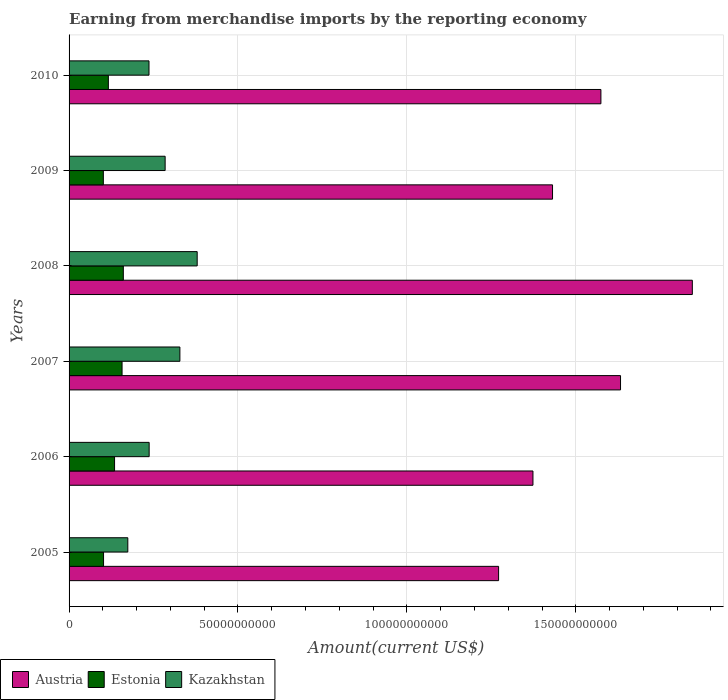Are the number of bars per tick equal to the number of legend labels?
Your answer should be very brief. Yes. What is the label of the 1st group of bars from the top?
Provide a short and direct response. 2010. What is the amount earned from merchandise imports in Kazakhstan in 2008?
Your response must be concise. 3.79e+1. Across all years, what is the maximum amount earned from merchandise imports in Kazakhstan?
Offer a terse response. 3.79e+1. Across all years, what is the minimum amount earned from merchandise imports in Austria?
Make the answer very short. 1.27e+11. In which year was the amount earned from merchandise imports in Austria minimum?
Give a very brief answer. 2005. What is the total amount earned from merchandise imports in Austria in the graph?
Give a very brief answer. 9.13e+11. What is the difference between the amount earned from merchandise imports in Estonia in 2007 and that in 2009?
Ensure brevity in your answer.  5.54e+09. What is the difference between the amount earned from merchandise imports in Kazakhstan in 2006 and the amount earned from merchandise imports in Austria in 2009?
Offer a terse response. -1.19e+11. What is the average amount earned from merchandise imports in Estonia per year?
Keep it short and to the point. 1.29e+1. In the year 2009, what is the difference between the amount earned from merchandise imports in Estonia and amount earned from merchandise imports in Kazakhstan?
Your response must be concise. -1.83e+1. What is the ratio of the amount earned from merchandise imports in Estonia in 2006 to that in 2009?
Your answer should be compact. 1.33. Is the amount earned from merchandise imports in Kazakhstan in 2008 less than that in 2010?
Provide a succinct answer. No. What is the difference between the highest and the second highest amount earned from merchandise imports in Estonia?
Ensure brevity in your answer.  3.73e+08. What is the difference between the highest and the lowest amount earned from merchandise imports in Estonia?
Make the answer very short. 5.91e+09. What does the 3rd bar from the top in 2008 represents?
Make the answer very short. Austria. What does the 3rd bar from the bottom in 2007 represents?
Keep it short and to the point. Kazakhstan. Is it the case that in every year, the sum of the amount earned from merchandise imports in Austria and amount earned from merchandise imports in Estonia is greater than the amount earned from merchandise imports in Kazakhstan?
Offer a very short reply. Yes. Are all the bars in the graph horizontal?
Offer a terse response. Yes. What is the difference between two consecutive major ticks on the X-axis?
Provide a short and direct response. 5.00e+1. Does the graph contain any zero values?
Keep it short and to the point. No. Where does the legend appear in the graph?
Offer a terse response. Bottom left. What is the title of the graph?
Offer a very short reply. Earning from merchandise imports by the reporting economy. What is the label or title of the X-axis?
Keep it short and to the point. Amount(current US$). What is the label or title of the Y-axis?
Offer a terse response. Years. What is the Amount(current US$) of Austria in 2005?
Give a very brief answer. 1.27e+11. What is the Amount(current US$) in Estonia in 2005?
Provide a short and direct response. 1.02e+1. What is the Amount(current US$) in Kazakhstan in 2005?
Offer a very short reply. 1.74e+1. What is the Amount(current US$) of Austria in 2006?
Your answer should be very brief. 1.37e+11. What is the Amount(current US$) of Estonia in 2006?
Your response must be concise. 1.35e+1. What is the Amount(current US$) of Kazakhstan in 2006?
Offer a very short reply. 2.37e+1. What is the Amount(current US$) of Austria in 2007?
Your answer should be very brief. 1.63e+11. What is the Amount(current US$) of Estonia in 2007?
Keep it short and to the point. 1.57e+1. What is the Amount(current US$) of Kazakhstan in 2007?
Provide a succinct answer. 3.28e+1. What is the Amount(current US$) in Austria in 2008?
Your response must be concise. 1.85e+11. What is the Amount(current US$) in Estonia in 2008?
Offer a very short reply. 1.61e+1. What is the Amount(current US$) of Kazakhstan in 2008?
Make the answer very short. 3.79e+1. What is the Amount(current US$) in Austria in 2009?
Provide a short and direct response. 1.43e+11. What is the Amount(current US$) of Estonia in 2009?
Your answer should be very brief. 1.01e+1. What is the Amount(current US$) of Kazakhstan in 2009?
Make the answer very short. 2.84e+1. What is the Amount(current US$) in Austria in 2010?
Offer a very short reply. 1.57e+11. What is the Amount(current US$) in Estonia in 2010?
Your response must be concise. 1.16e+1. What is the Amount(current US$) in Kazakhstan in 2010?
Provide a succinct answer. 2.37e+1. Across all years, what is the maximum Amount(current US$) of Austria?
Ensure brevity in your answer.  1.85e+11. Across all years, what is the maximum Amount(current US$) in Estonia?
Provide a short and direct response. 1.61e+1. Across all years, what is the maximum Amount(current US$) in Kazakhstan?
Ensure brevity in your answer.  3.79e+1. Across all years, what is the minimum Amount(current US$) in Austria?
Give a very brief answer. 1.27e+11. Across all years, what is the minimum Amount(current US$) of Estonia?
Provide a short and direct response. 1.01e+1. Across all years, what is the minimum Amount(current US$) in Kazakhstan?
Your response must be concise. 1.74e+1. What is the total Amount(current US$) of Austria in the graph?
Your response must be concise. 9.13e+11. What is the total Amount(current US$) of Estonia in the graph?
Your response must be concise. 7.72e+1. What is the total Amount(current US$) in Kazakhstan in the graph?
Give a very brief answer. 1.64e+11. What is the difference between the Amount(current US$) in Austria in 2005 and that in 2006?
Offer a very short reply. -1.02e+1. What is the difference between the Amount(current US$) in Estonia in 2005 and that in 2006?
Provide a succinct answer. -3.26e+09. What is the difference between the Amount(current US$) in Kazakhstan in 2005 and that in 2006?
Offer a terse response. -6.32e+09. What is the difference between the Amount(current US$) of Austria in 2005 and that in 2007?
Keep it short and to the point. -3.61e+1. What is the difference between the Amount(current US$) of Estonia in 2005 and that in 2007?
Your answer should be compact. -5.48e+09. What is the difference between the Amount(current US$) of Kazakhstan in 2005 and that in 2007?
Offer a terse response. -1.54e+1. What is the difference between the Amount(current US$) of Austria in 2005 and that in 2008?
Your response must be concise. -5.74e+1. What is the difference between the Amount(current US$) in Estonia in 2005 and that in 2008?
Provide a succinct answer. -5.85e+09. What is the difference between the Amount(current US$) of Kazakhstan in 2005 and that in 2008?
Offer a very short reply. -2.05e+1. What is the difference between the Amount(current US$) in Austria in 2005 and that in 2009?
Your answer should be very brief. -1.60e+1. What is the difference between the Amount(current US$) of Estonia in 2005 and that in 2009?
Provide a short and direct response. 6.10e+07. What is the difference between the Amount(current US$) in Kazakhstan in 2005 and that in 2009?
Provide a short and direct response. -1.11e+1. What is the difference between the Amount(current US$) in Austria in 2005 and that in 2010?
Offer a very short reply. -3.03e+1. What is the difference between the Amount(current US$) in Estonia in 2005 and that in 2010?
Give a very brief answer. -1.42e+09. What is the difference between the Amount(current US$) of Kazakhstan in 2005 and that in 2010?
Keep it short and to the point. -6.27e+09. What is the difference between the Amount(current US$) of Austria in 2006 and that in 2007?
Keep it short and to the point. -2.59e+1. What is the difference between the Amount(current US$) in Estonia in 2006 and that in 2007?
Your answer should be very brief. -2.22e+09. What is the difference between the Amount(current US$) in Kazakhstan in 2006 and that in 2007?
Your answer should be compact. -9.10e+09. What is the difference between the Amount(current US$) in Austria in 2006 and that in 2008?
Keep it short and to the point. -4.72e+1. What is the difference between the Amount(current US$) of Estonia in 2006 and that in 2008?
Offer a very short reply. -2.60e+09. What is the difference between the Amount(current US$) in Kazakhstan in 2006 and that in 2008?
Your response must be concise. -1.42e+1. What is the difference between the Amount(current US$) in Austria in 2006 and that in 2009?
Your answer should be compact. -5.80e+09. What is the difference between the Amount(current US$) in Estonia in 2006 and that in 2009?
Ensure brevity in your answer.  3.32e+09. What is the difference between the Amount(current US$) in Kazakhstan in 2006 and that in 2009?
Keep it short and to the point. -4.73e+09. What is the difference between the Amount(current US$) of Austria in 2006 and that in 2010?
Your answer should be very brief. -2.01e+1. What is the difference between the Amount(current US$) of Estonia in 2006 and that in 2010?
Your answer should be very brief. 1.84e+09. What is the difference between the Amount(current US$) in Kazakhstan in 2006 and that in 2010?
Keep it short and to the point. 4.84e+07. What is the difference between the Amount(current US$) in Austria in 2007 and that in 2008?
Provide a short and direct response. -2.13e+1. What is the difference between the Amount(current US$) in Estonia in 2007 and that in 2008?
Your answer should be very brief. -3.73e+08. What is the difference between the Amount(current US$) of Kazakhstan in 2007 and that in 2008?
Offer a terse response. -5.12e+09. What is the difference between the Amount(current US$) of Austria in 2007 and that in 2009?
Make the answer very short. 2.01e+1. What is the difference between the Amount(current US$) in Estonia in 2007 and that in 2009?
Keep it short and to the point. 5.54e+09. What is the difference between the Amount(current US$) of Kazakhstan in 2007 and that in 2009?
Provide a short and direct response. 4.37e+09. What is the difference between the Amount(current US$) of Austria in 2007 and that in 2010?
Provide a short and direct response. 5.81e+09. What is the difference between the Amount(current US$) of Estonia in 2007 and that in 2010?
Give a very brief answer. 4.06e+09. What is the difference between the Amount(current US$) of Kazakhstan in 2007 and that in 2010?
Give a very brief answer. 9.14e+09. What is the difference between the Amount(current US$) of Austria in 2008 and that in 2009?
Ensure brevity in your answer.  4.14e+1. What is the difference between the Amount(current US$) of Estonia in 2008 and that in 2009?
Provide a succinct answer. 5.91e+09. What is the difference between the Amount(current US$) of Kazakhstan in 2008 and that in 2009?
Offer a very short reply. 9.49e+09. What is the difference between the Amount(current US$) of Austria in 2008 and that in 2010?
Your response must be concise. 2.71e+1. What is the difference between the Amount(current US$) in Estonia in 2008 and that in 2010?
Ensure brevity in your answer.  4.43e+09. What is the difference between the Amount(current US$) of Kazakhstan in 2008 and that in 2010?
Your answer should be very brief. 1.43e+1. What is the difference between the Amount(current US$) in Austria in 2009 and that in 2010?
Give a very brief answer. -1.43e+1. What is the difference between the Amount(current US$) of Estonia in 2009 and that in 2010?
Offer a terse response. -1.48e+09. What is the difference between the Amount(current US$) in Kazakhstan in 2009 and that in 2010?
Your response must be concise. 4.78e+09. What is the difference between the Amount(current US$) in Austria in 2005 and the Amount(current US$) in Estonia in 2006?
Your answer should be very brief. 1.14e+11. What is the difference between the Amount(current US$) in Austria in 2005 and the Amount(current US$) in Kazakhstan in 2006?
Your answer should be very brief. 1.03e+11. What is the difference between the Amount(current US$) of Estonia in 2005 and the Amount(current US$) of Kazakhstan in 2006?
Make the answer very short. -1.35e+1. What is the difference between the Amount(current US$) in Austria in 2005 and the Amount(current US$) in Estonia in 2007?
Offer a very short reply. 1.11e+11. What is the difference between the Amount(current US$) in Austria in 2005 and the Amount(current US$) in Kazakhstan in 2007?
Offer a very short reply. 9.43e+1. What is the difference between the Amount(current US$) of Estonia in 2005 and the Amount(current US$) of Kazakhstan in 2007?
Your response must be concise. -2.26e+1. What is the difference between the Amount(current US$) of Austria in 2005 and the Amount(current US$) of Estonia in 2008?
Ensure brevity in your answer.  1.11e+11. What is the difference between the Amount(current US$) in Austria in 2005 and the Amount(current US$) in Kazakhstan in 2008?
Offer a terse response. 8.92e+1. What is the difference between the Amount(current US$) in Estonia in 2005 and the Amount(current US$) in Kazakhstan in 2008?
Your answer should be compact. -2.77e+1. What is the difference between the Amount(current US$) of Austria in 2005 and the Amount(current US$) of Estonia in 2009?
Provide a succinct answer. 1.17e+11. What is the difference between the Amount(current US$) in Austria in 2005 and the Amount(current US$) in Kazakhstan in 2009?
Provide a short and direct response. 9.87e+1. What is the difference between the Amount(current US$) in Estonia in 2005 and the Amount(current US$) in Kazakhstan in 2009?
Keep it short and to the point. -1.82e+1. What is the difference between the Amount(current US$) in Austria in 2005 and the Amount(current US$) in Estonia in 2010?
Provide a succinct answer. 1.16e+11. What is the difference between the Amount(current US$) of Austria in 2005 and the Amount(current US$) of Kazakhstan in 2010?
Ensure brevity in your answer.  1.03e+11. What is the difference between the Amount(current US$) in Estonia in 2005 and the Amount(current US$) in Kazakhstan in 2010?
Keep it short and to the point. -1.35e+1. What is the difference between the Amount(current US$) in Austria in 2006 and the Amount(current US$) in Estonia in 2007?
Provide a short and direct response. 1.22e+11. What is the difference between the Amount(current US$) in Austria in 2006 and the Amount(current US$) in Kazakhstan in 2007?
Your answer should be very brief. 1.05e+11. What is the difference between the Amount(current US$) of Estonia in 2006 and the Amount(current US$) of Kazakhstan in 2007?
Provide a short and direct response. -1.93e+1. What is the difference between the Amount(current US$) in Austria in 2006 and the Amount(current US$) in Estonia in 2008?
Offer a very short reply. 1.21e+11. What is the difference between the Amount(current US$) of Austria in 2006 and the Amount(current US$) of Kazakhstan in 2008?
Your answer should be compact. 9.94e+1. What is the difference between the Amount(current US$) in Estonia in 2006 and the Amount(current US$) in Kazakhstan in 2008?
Ensure brevity in your answer.  -2.45e+1. What is the difference between the Amount(current US$) of Austria in 2006 and the Amount(current US$) of Estonia in 2009?
Provide a succinct answer. 1.27e+11. What is the difference between the Amount(current US$) of Austria in 2006 and the Amount(current US$) of Kazakhstan in 2009?
Offer a terse response. 1.09e+11. What is the difference between the Amount(current US$) of Estonia in 2006 and the Amount(current US$) of Kazakhstan in 2009?
Make the answer very short. -1.50e+1. What is the difference between the Amount(current US$) in Austria in 2006 and the Amount(current US$) in Estonia in 2010?
Give a very brief answer. 1.26e+11. What is the difference between the Amount(current US$) in Austria in 2006 and the Amount(current US$) in Kazakhstan in 2010?
Your response must be concise. 1.14e+11. What is the difference between the Amount(current US$) of Estonia in 2006 and the Amount(current US$) of Kazakhstan in 2010?
Offer a terse response. -1.02e+1. What is the difference between the Amount(current US$) of Austria in 2007 and the Amount(current US$) of Estonia in 2008?
Your response must be concise. 1.47e+11. What is the difference between the Amount(current US$) in Austria in 2007 and the Amount(current US$) in Kazakhstan in 2008?
Offer a very short reply. 1.25e+11. What is the difference between the Amount(current US$) in Estonia in 2007 and the Amount(current US$) in Kazakhstan in 2008?
Give a very brief answer. -2.22e+1. What is the difference between the Amount(current US$) of Austria in 2007 and the Amount(current US$) of Estonia in 2009?
Keep it short and to the point. 1.53e+11. What is the difference between the Amount(current US$) of Austria in 2007 and the Amount(current US$) of Kazakhstan in 2009?
Provide a short and direct response. 1.35e+11. What is the difference between the Amount(current US$) of Estonia in 2007 and the Amount(current US$) of Kazakhstan in 2009?
Your response must be concise. -1.27e+1. What is the difference between the Amount(current US$) in Austria in 2007 and the Amount(current US$) in Estonia in 2010?
Offer a terse response. 1.52e+11. What is the difference between the Amount(current US$) in Austria in 2007 and the Amount(current US$) in Kazakhstan in 2010?
Offer a terse response. 1.40e+11. What is the difference between the Amount(current US$) in Estonia in 2007 and the Amount(current US$) in Kazakhstan in 2010?
Your answer should be compact. -7.97e+09. What is the difference between the Amount(current US$) of Austria in 2008 and the Amount(current US$) of Estonia in 2009?
Provide a short and direct response. 1.74e+11. What is the difference between the Amount(current US$) of Austria in 2008 and the Amount(current US$) of Kazakhstan in 2009?
Your response must be concise. 1.56e+11. What is the difference between the Amount(current US$) in Estonia in 2008 and the Amount(current US$) in Kazakhstan in 2009?
Make the answer very short. -1.24e+1. What is the difference between the Amount(current US$) of Austria in 2008 and the Amount(current US$) of Estonia in 2010?
Provide a short and direct response. 1.73e+11. What is the difference between the Amount(current US$) of Austria in 2008 and the Amount(current US$) of Kazakhstan in 2010?
Offer a very short reply. 1.61e+11. What is the difference between the Amount(current US$) in Estonia in 2008 and the Amount(current US$) in Kazakhstan in 2010?
Offer a terse response. -7.60e+09. What is the difference between the Amount(current US$) in Austria in 2009 and the Amount(current US$) in Estonia in 2010?
Offer a very short reply. 1.31e+11. What is the difference between the Amount(current US$) of Austria in 2009 and the Amount(current US$) of Kazakhstan in 2010?
Provide a succinct answer. 1.19e+11. What is the difference between the Amount(current US$) of Estonia in 2009 and the Amount(current US$) of Kazakhstan in 2010?
Give a very brief answer. -1.35e+1. What is the average Amount(current US$) of Austria per year?
Keep it short and to the point. 1.52e+11. What is the average Amount(current US$) of Estonia per year?
Your answer should be compact. 1.29e+1. What is the average Amount(current US$) of Kazakhstan per year?
Your answer should be compact. 2.73e+1. In the year 2005, what is the difference between the Amount(current US$) of Austria and Amount(current US$) of Estonia?
Ensure brevity in your answer.  1.17e+11. In the year 2005, what is the difference between the Amount(current US$) of Austria and Amount(current US$) of Kazakhstan?
Make the answer very short. 1.10e+11. In the year 2005, what is the difference between the Amount(current US$) in Estonia and Amount(current US$) in Kazakhstan?
Provide a succinct answer. -7.18e+09. In the year 2006, what is the difference between the Amount(current US$) of Austria and Amount(current US$) of Estonia?
Offer a terse response. 1.24e+11. In the year 2006, what is the difference between the Amount(current US$) of Austria and Amount(current US$) of Kazakhstan?
Ensure brevity in your answer.  1.14e+11. In the year 2006, what is the difference between the Amount(current US$) in Estonia and Amount(current US$) in Kazakhstan?
Keep it short and to the point. -1.02e+1. In the year 2007, what is the difference between the Amount(current US$) of Austria and Amount(current US$) of Estonia?
Your answer should be very brief. 1.48e+11. In the year 2007, what is the difference between the Amount(current US$) of Austria and Amount(current US$) of Kazakhstan?
Give a very brief answer. 1.30e+11. In the year 2007, what is the difference between the Amount(current US$) in Estonia and Amount(current US$) in Kazakhstan?
Ensure brevity in your answer.  -1.71e+1. In the year 2008, what is the difference between the Amount(current US$) of Austria and Amount(current US$) of Estonia?
Your response must be concise. 1.68e+11. In the year 2008, what is the difference between the Amount(current US$) in Austria and Amount(current US$) in Kazakhstan?
Make the answer very short. 1.47e+11. In the year 2008, what is the difference between the Amount(current US$) of Estonia and Amount(current US$) of Kazakhstan?
Your answer should be very brief. -2.19e+1. In the year 2009, what is the difference between the Amount(current US$) of Austria and Amount(current US$) of Estonia?
Offer a terse response. 1.33e+11. In the year 2009, what is the difference between the Amount(current US$) in Austria and Amount(current US$) in Kazakhstan?
Give a very brief answer. 1.15e+11. In the year 2009, what is the difference between the Amount(current US$) of Estonia and Amount(current US$) of Kazakhstan?
Your response must be concise. -1.83e+1. In the year 2010, what is the difference between the Amount(current US$) in Austria and Amount(current US$) in Estonia?
Provide a succinct answer. 1.46e+11. In the year 2010, what is the difference between the Amount(current US$) of Austria and Amount(current US$) of Kazakhstan?
Provide a short and direct response. 1.34e+11. In the year 2010, what is the difference between the Amount(current US$) in Estonia and Amount(current US$) in Kazakhstan?
Make the answer very short. -1.20e+1. What is the ratio of the Amount(current US$) of Austria in 2005 to that in 2006?
Offer a very short reply. 0.93. What is the ratio of the Amount(current US$) of Estonia in 2005 to that in 2006?
Make the answer very short. 0.76. What is the ratio of the Amount(current US$) in Kazakhstan in 2005 to that in 2006?
Provide a short and direct response. 0.73. What is the ratio of the Amount(current US$) of Austria in 2005 to that in 2007?
Make the answer very short. 0.78. What is the ratio of the Amount(current US$) of Estonia in 2005 to that in 2007?
Keep it short and to the point. 0.65. What is the ratio of the Amount(current US$) of Kazakhstan in 2005 to that in 2007?
Your response must be concise. 0.53. What is the ratio of the Amount(current US$) in Austria in 2005 to that in 2008?
Keep it short and to the point. 0.69. What is the ratio of the Amount(current US$) of Estonia in 2005 to that in 2008?
Your answer should be very brief. 0.64. What is the ratio of the Amount(current US$) in Kazakhstan in 2005 to that in 2008?
Provide a short and direct response. 0.46. What is the ratio of the Amount(current US$) in Austria in 2005 to that in 2009?
Provide a short and direct response. 0.89. What is the ratio of the Amount(current US$) in Estonia in 2005 to that in 2009?
Provide a succinct answer. 1.01. What is the ratio of the Amount(current US$) in Kazakhstan in 2005 to that in 2009?
Make the answer very short. 0.61. What is the ratio of the Amount(current US$) of Austria in 2005 to that in 2010?
Your response must be concise. 0.81. What is the ratio of the Amount(current US$) in Estonia in 2005 to that in 2010?
Keep it short and to the point. 0.88. What is the ratio of the Amount(current US$) in Kazakhstan in 2005 to that in 2010?
Provide a short and direct response. 0.73. What is the ratio of the Amount(current US$) in Austria in 2006 to that in 2007?
Keep it short and to the point. 0.84. What is the ratio of the Amount(current US$) of Estonia in 2006 to that in 2007?
Provide a short and direct response. 0.86. What is the ratio of the Amount(current US$) in Kazakhstan in 2006 to that in 2007?
Your answer should be very brief. 0.72. What is the ratio of the Amount(current US$) of Austria in 2006 to that in 2008?
Offer a terse response. 0.74. What is the ratio of the Amount(current US$) of Estonia in 2006 to that in 2008?
Provide a short and direct response. 0.84. What is the ratio of the Amount(current US$) in Kazakhstan in 2006 to that in 2008?
Provide a short and direct response. 0.63. What is the ratio of the Amount(current US$) of Austria in 2006 to that in 2009?
Keep it short and to the point. 0.96. What is the ratio of the Amount(current US$) in Estonia in 2006 to that in 2009?
Keep it short and to the point. 1.33. What is the ratio of the Amount(current US$) of Kazakhstan in 2006 to that in 2009?
Offer a very short reply. 0.83. What is the ratio of the Amount(current US$) in Austria in 2006 to that in 2010?
Your answer should be very brief. 0.87. What is the ratio of the Amount(current US$) in Estonia in 2006 to that in 2010?
Offer a very short reply. 1.16. What is the ratio of the Amount(current US$) in Kazakhstan in 2006 to that in 2010?
Make the answer very short. 1. What is the ratio of the Amount(current US$) of Austria in 2007 to that in 2008?
Make the answer very short. 0.88. What is the ratio of the Amount(current US$) in Estonia in 2007 to that in 2008?
Your answer should be very brief. 0.98. What is the ratio of the Amount(current US$) of Kazakhstan in 2007 to that in 2008?
Ensure brevity in your answer.  0.86. What is the ratio of the Amount(current US$) in Austria in 2007 to that in 2009?
Provide a succinct answer. 1.14. What is the ratio of the Amount(current US$) of Estonia in 2007 to that in 2009?
Make the answer very short. 1.55. What is the ratio of the Amount(current US$) in Kazakhstan in 2007 to that in 2009?
Provide a short and direct response. 1.15. What is the ratio of the Amount(current US$) of Austria in 2007 to that in 2010?
Your answer should be very brief. 1.04. What is the ratio of the Amount(current US$) of Estonia in 2007 to that in 2010?
Your answer should be very brief. 1.35. What is the ratio of the Amount(current US$) in Kazakhstan in 2007 to that in 2010?
Your response must be concise. 1.39. What is the ratio of the Amount(current US$) in Austria in 2008 to that in 2009?
Offer a very short reply. 1.29. What is the ratio of the Amount(current US$) of Estonia in 2008 to that in 2009?
Ensure brevity in your answer.  1.58. What is the ratio of the Amount(current US$) of Kazakhstan in 2008 to that in 2009?
Keep it short and to the point. 1.33. What is the ratio of the Amount(current US$) in Austria in 2008 to that in 2010?
Offer a terse response. 1.17. What is the ratio of the Amount(current US$) in Estonia in 2008 to that in 2010?
Offer a terse response. 1.38. What is the ratio of the Amount(current US$) of Kazakhstan in 2008 to that in 2010?
Offer a very short reply. 1.6. What is the ratio of the Amount(current US$) of Austria in 2009 to that in 2010?
Offer a terse response. 0.91. What is the ratio of the Amount(current US$) of Estonia in 2009 to that in 2010?
Your response must be concise. 0.87. What is the ratio of the Amount(current US$) of Kazakhstan in 2009 to that in 2010?
Offer a terse response. 1.2. What is the difference between the highest and the second highest Amount(current US$) of Austria?
Offer a terse response. 2.13e+1. What is the difference between the highest and the second highest Amount(current US$) in Estonia?
Ensure brevity in your answer.  3.73e+08. What is the difference between the highest and the second highest Amount(current US$) of Kazakhstan?
Provide a succinct answer. 5.12e+09. What is the difference between the highest and the lowest Amount(current US$) in Austria?
Provide a short and direct response. 5.74e+1. What is the difference between the highest and the lowest Amount(current US$) of Estonia?
Your answer should be very brief. 5.91e+09. What is the difference between the highest and the lowest Amount(current US$) in Kazakhstan?
Make the answer very short. 2.05e+1. 